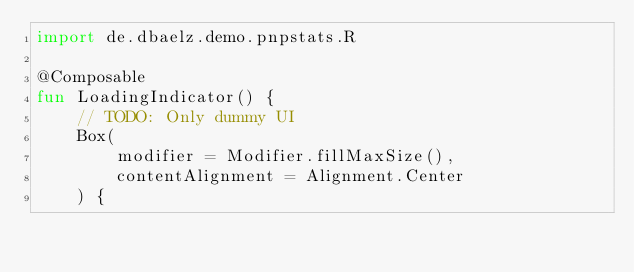<code> <loc_0><loc_0><loc_500><loc_500><_Kotlin_>import de.dbaelz.demo.pnpstats.R

@Composable
fun LoadingIndicator() {
    // TODO: Only dummy UI
    Box(
        modifier = Modifier.fillMaxSize(),
        contentAlignment = Alignment.Center
    ) {</code> 